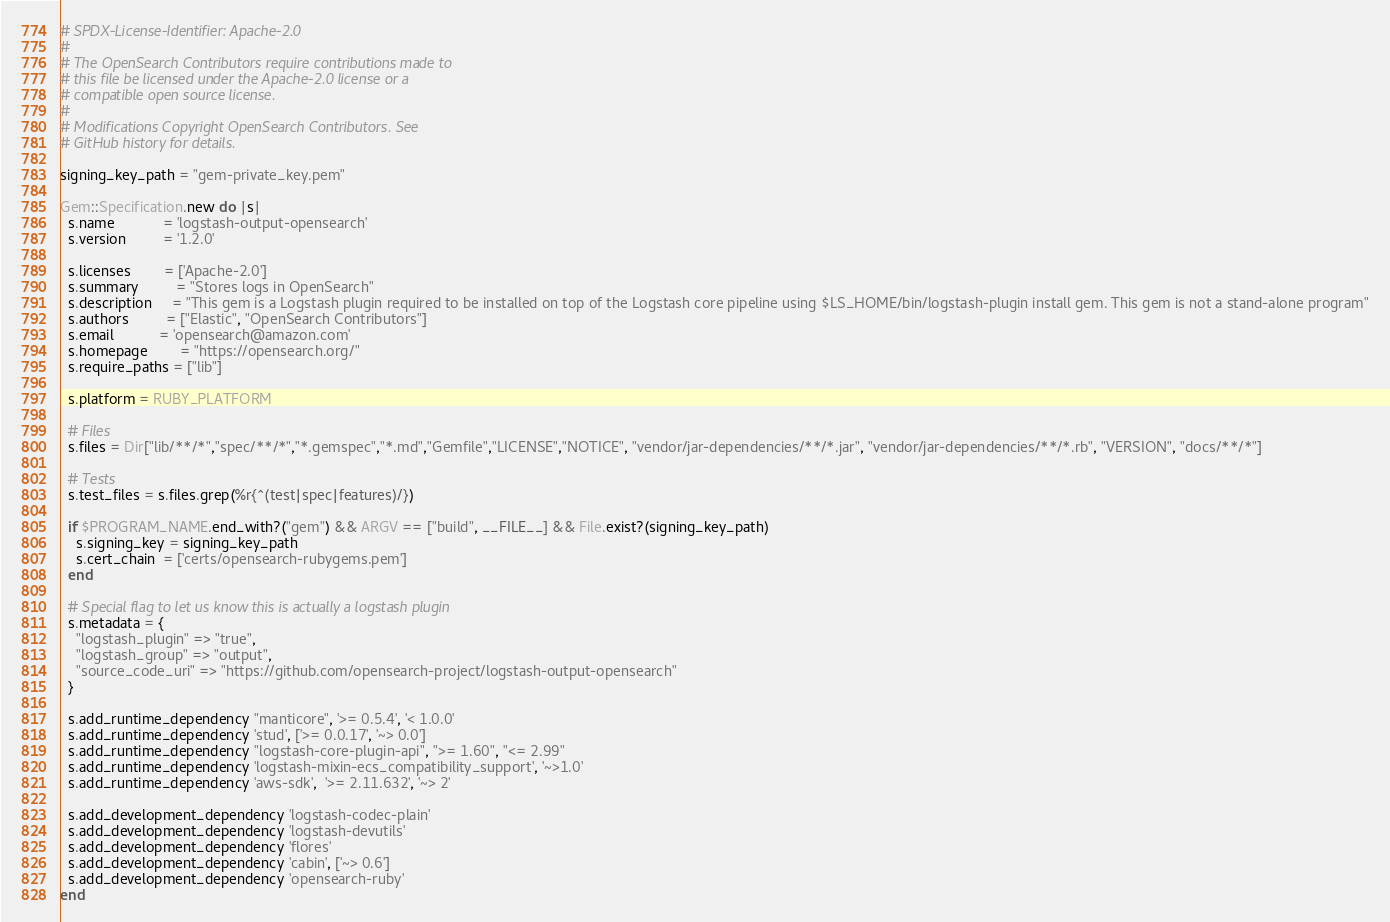<code> <loc_0><loc_0><loc_500><loc_500><_Ruby_># SPDX-License-Identifier: Apache-2.0
#
# The OpenSearch Contributors require contributions made to
# this file be licensed under the Apache-2.0 license or a
# compatible open source license.
#
# Modifications Copyright OpenSearch Contributors. See
# GitHub history for details.

signing_key_path = "gem-private_key.pem"

Gem::Specification.new do |s|
  s.name            = 'logstash-output-opensearch'
  s.version         = '1.2.0'

  s.licenses        = ['Apache-2.0']
  s.summary         = "Stores logs in OpenSearch"
  s.description     = "This gem is a Logstash plugin required to be installed on top of the Logstash core pipeline using $LS_HOME/bin/logstash-plugin install gem. This gem is not a stand-alone program"
  s.authors         = ["Elastic", "OpenSearch Contributors"]
  s.email           = 'opensearch@amazon.com'
  s.homepage        = "https://opensearch.org/"
  s.require_paths = ["lib"]

  s.platform = RUBY_PLATFORM

  # Files
  s.files = Dir["lib/**/*","spec/**/*","*.gemspec","*.md","Gemfile","LICENSE","NOTICE", "vendor/jar-dependencies/**/*.jar", "vendor/jar-dependencies/**/*.rb", "VERSION", "docs/**/*"]

  # Tests
  s.test_files = s.files.grep(%r{^(test|spec|features)/})

  if $PROGRAM_NAME.end_with?("gem") && ARGV == ["build", __FILE__] && File.exist?(signing_key_path)
    s.signing_key = signing_key_path
    s.cert_chain  = ['certs/opensearch-rubygems.pem']
  end

  # Special flag to let us know this is actually a logstash plugin
  s.metadata = {
    "logstash_plugin" => "true",
    "logstash_group" => "output",
    "source_code_uri" => "https://github.com/opensearch-project/logstash-output-opensearch"
  }

  s.add_runtime_dependency "manticore", '>= 0.5.4', '< 1.0.0'
  s.add_runtime_dependency 'stud', ['>= 0.0.17', '~> 0.0']
  s.add_runtime_dependency "logstash-core-plugin-api", ">= 1.60", "<= 2.99"
  s.add_runtime_dependency 'logstash-mixin-ecs_compatibility_support', '~>1.0'
  s.add_runtime_dependency 'aws-sdk',  '>= 2.11.632', '~> 2'

  s.add_development_dependency 'logstash-codec-plain'
  s.add_development_dependency 'logstash-devutils'
  s.add_development_dependency 'flores'
  s.add_development_dependency 'cabin', ['~> 0.6']
  s.add_development_dependency 'opensearch-ruby'
end
</code> 